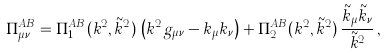Convert formula to latex. <formula><loc_0><loc_0><loc_500><loc_500>\Pi _ { \mu \nu } ^ { A B } = \Pi _ { 1 } ^ { A B } ( k ^ { 2 } , \tilde { k } ^ { 2 } ) \, \left ( k ^ { 2 } g _ { \mu \nu } - k _ { \mu } k _ { \nu } \right ) + \Pi _ { 2 } ^ { A B } ( k ^ { 2 } , \tilde { k } ^ { 2 } ) \, \frac { \tilde { k } _ { \mu } \tilde { k } _ { \nu } } { \tilde { k } ^ { 2 } } \, ,</formula> 